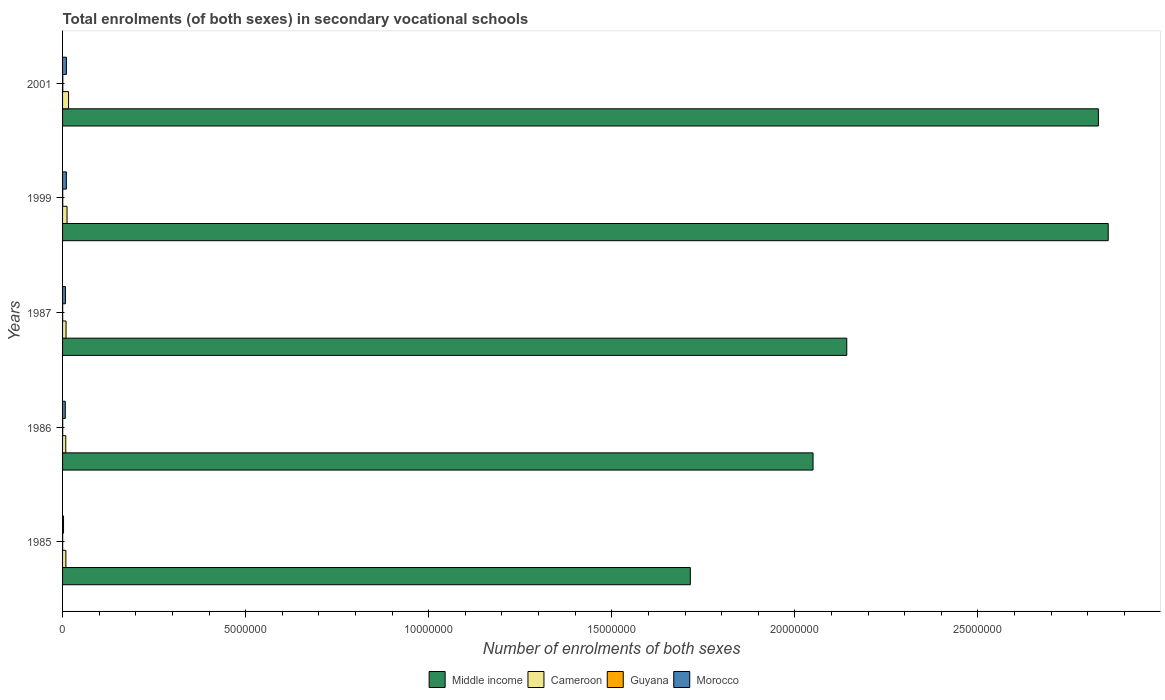How many bars are there on the 1st tick from the top?
Keep it short and to the point. 4. What is the number of enrolments in secondary schools in Cameroon in 1999?
Keep it short and to the point. 1.22e+05. Across all years, what is the maximum number of enrolments in secondary schools in Cameroon?
Your response must be concise. 1.64e+05. Across all years, what is the minimum number of enrolments in secondary schools in Morocco?
Ensure brevity in your answer.  2.65e+04. In which year was the number of enrolments in secondary schools in Guyana minimum?
Provide a succinct answer. 1985. What is the total number of enrolments in secondary schools in Morocco in the graph?
Keep it short and to the point. 3.86e+05. What is the difference between the number of enrolments in secondary schools in Middle income in 1987 and that in 1999?
Provide a succinct answer. -7.14e+06. What is the difference between the number of enrolments in secondary schools in Cameroon in 1985 and the number of enrolments in secondary schools in Middle income in 2001?
Your answer should be compact. -2.82e+07. What is the average number of enrolments in secondary schools in Cameroon per year?
Keep it short and to the point. 1.12e+05. In the year 1999, what is the difference between the number of enrolments in secondary schools in Middle income and number of enrolments in secondary schools in Morocco?
Give a very brief answer. 2.85e+07. In how many years, is the number of enrolments in secondary schools in Morocco greater than 25000000 ?
Your answer should be very brief. 0. What is the ratio of the number of enrolments in secondary schools in Cameroon in 1999 to that in 2001?
Provide a short and direct response. 0.75. What is the difference between the highest and the second highest number of enrolments in secondary schools in Guyana?
Your response must be concise. 1757. What is the difference between the highest and the lowest number of enrolments in secondary schools in Morocco?
Your response must be concise. 7.82e+04. Is it the case that in every year, the sum of the number of enrolments in secondary schools in Cameroon and number of enrolments in secondary schools in Morocco is greater than the sum of number of enrolments in secondary schools in Middle income and number of enrolments in secondary schools in Guyana?
Provide a short and direct response. No. Is it the case that in every year, the sum of the number of enrolments in secondary schools in Cameroon and number of enrolments in secondary schools in Morocco is greater than the number of enrolments in secondary schools in Middle income?
Your answer should be very brief. No. How many bars are there?
Offer a very short reply. 20. Are all the bars in the graph horizontal?
Your response must be concise. Yes. Does the graph contain any zero values?
Offer a terse response. No. Does the graph contain grids?
Ensure brevity in your answer.  No. Where does the legend appear in the graph?
Ensure brevity in your answer.  Bottom center. What is the title of the graph?
Provide a succinct answer. Total enrolments (of both sexes) in secondary vocational schools. Does "High income" appear as one of the legend labels in the graph?
Your answer should be compact. No. What is the label or title of the X-axis?
Make the answer very short. Number of enrolments of both sexes. What is the Number of enrolments of both sexes in Middle income in 1985?
Provide a short and direct response. 1.71e+07. What is the Number of enrolments of both sexes in Cameroon in 1985?
Offer a very short reply. 9.03e+04. What is the Number of enrolments of both sexes in Guyana in 1985?
Provide a short and direct response. 2509. What is the Number of enrolments of both sexes of Morocco in 1985?
Ensure brevity in your answer.  2.65e+04. What is the Number of enrolments of both sexes in Middle income in 1986?
Your answer should be compact. 2.05e+07. What is the Number of enrolments of both sexes in Cameroon in 1986?
Ensure brevity in your answer.  8.73e+04. What is the Number of enrolments of both sexes in Guyana in 1986?
Provide a succinct answer. 3867. What is the Number of enrolments of both sexes in Morocco in 1986?
Make the answer very short. 7.41e+04. What is the Number of enrolments of both sexes in Middle income in 1987?
Your answer should be very brief. 2.14e+07. What is the Number of enrolments of both sexes of Cameroon in 1987?
Your response must be concise. 9.50e+04. What is the Number of enrolments of both sexes in Guyana in 1987?
Offer a very short reply. 2594. What is the Number of enrolments of both sexes in Morocco in 1987?
Offer a terse response. 7.75e+04. What is the Number of enrolments of both sexes in Middle income in 1999?
Keep it short and to the point. 2.86e+07. What is the Number of enrolments of both sexes in Cameroon in 1999?
Your answer should be very brief. 1.22e+05. What is the Number of enrolments of both sexes of Guyana in 1999?
Keep it short and to the point. 4453. What is the Number of enrolments of both sexes of Morocco in 1999?
Offer a very short reply. 1.03e+05. What is the Number of enrolments of both sexes in Middle income in 2001?
Offer a very short reply. 2.83e+07. What is the Number of enrolments of both sexes of Cameroon in 2001?
Your response must be concise. 1.64e+05. What is the Number of enrolments of both sexes of Guyana in 2001?
Offer a terse response. 6210. What is the Number of enrolments of both sexes in Morocco in 2001?
Keep it short and to the point. 1.05e+05. Across all years, what is the maximum Number of enrolments of both sexes of Middle income?
Your answer should be compact. 2.86e+07. Across all years, what is the maximum Number of enrolments of both sexes in Cameroon?
Ensure brevity in your answer.  1.64e+05. Across all years, what is the maximum Number of enrolments of both sexes of Guyana?
Your response must be concise. 6210. Across all years, what is the maximum Number of enrolments of both sexes of Morocco?
Your response must be concise. 1.05e+05. Across all years, what is the minimum Number of enrolments of both sexes in Middle income?
Keep it short and to the point. 1.71e+07. Across all years, what is the minimum Number of enrolments of both sexes in Cameroon?
Offer a terse response. 8.73e+04. Across all years, what is the minimum Number of enrolments of both sexes of Guyana?
Keep it short and to the point. 2509. Across all years, what is the minimum Number of enrolments of both sexes of Morocco?
Your response must be concise. 2.65e+04. What is the total Number of enrolments of both sexes in Middle income in the graph?
Your answer should be very brief. 1.16e+08. What is the total Number of enrolments of both sexes in Cameroon in the graph?
Your answer should be very brief. 5.58e+05. What is the total Number of enrolments of both sexes in Guyana in the graph?
Your response must be concise. 1.96e+04. What is the total Number of enrolments of both sexes in Morocco in the graph?
Your answer should be compact. 3.86e+05. What is the difference between the Number of enrolments of both sexes in Middle income in 1985 and that in 1986?
Your answer should be very brief. -3.35e+06. What is the difference between the Number of enrolments of both sexes of Cameroon in 1985 and that in 1986?
Your answer should be very brief. 3081. What is the difference between the Number of enrolments of both sexes in Guyana in 1985 and that in 1986?
Give a very brief answer. -1358. What is the difference between the Number of enrolments of both sexes of Morocco in 1985 and that in 1986?
Your response must be concise. -4.76e+04. What is the difference between the Number of enrolments of both sexes of Middle income in 1985 and that in 1987?
Provide a short and direct response. -4.27e+06. What is the difference between the Number of enrolments of both sexes in Cameroon in 1985 and that in 1987?
Make the answer very short. -4677. What is the difference between the Number of enrolments of both sexes of Guyana in 1985 and that in 1987?
Offer a terse response. -85. What is the difference between the Number of enrolments of both sexes in Morocco in 1985 and that in 1987?
Keep it short and to the point. -5.10e+04. What is the difference between the Number of enrolments of both sexes of Middle income in 1985 and that in 1999?
Give a very brief answer. -1.14e+07. What is the difference between the Number of enrolments of both sexes in Cameroon in 1985 and that in 1999?
Make the answer very short. -3.18e+04. What is the difference between the Number of enrolments of both sexes of Guyana in 1985 and that in 1999?
Offer a terse response. -1944. What is the difference between the Number of enrolments of both sexes of Morocco in 1985 and that in 1999?
Offer a very short reply. -7.69e+04. What is the difference between the Number of enrolments of both sexes of Middle income in 1985 and that in 2001?
Keep it short and to the point. -1.11e+07. What is the difference between the Number of enrolments of both sexes in Cameroon in 1985 and that in 2001?
Ensure brevity in your answer.  -7.33e+04. What is the difference between the Number of enrolments of both sexes in Guyana in 1985 and that in 2001?
Provide a short and direct response. -3701. What is the difference between the Number of enrolments of both sexes of Morocco in 1985 and that in 2001?
Your answer should be very brief. -7.82e+04. What is the difference between the Number of enrolments of both sexes of Middle income in 1986 and that in 1987?
Offer a terse response. -9.21e+05. What is the difference between the Number of enrolments of both sexes in Cameroon in 1986 and that in 1987?
Your answer should be very brief. -7758. What is the difference between the Number of enrolments of both sexes of Guyana in 1986 and that in 1987?
Provide a succinct answer. 1273. What is the difference between the Number of enrolments of both sexes in Morocco in 1986 and that in 1987?
Give a very brief answer. -3397. What is the difference between the Number of enrolments of both sexes in Middle income in 1986 and that in 1999?
Your answer should be compact. -8.06e+06. What is the difference between the Number of enrolments of both sexes of Cameroon in 1986 and that in 1999?
Keep it short and to the point. -3.49e+04. What is the difference between the Number of enrolments of both sexes of Guyana in 1986 and that in 1999?
Your answer should be very brief. -586. What is the difference between the Number of enrolments of both sexes in Morocco in 1986 and that in 1999?
Give a very brief answer. -2.93e+04. What is the difference between the Number of enrolments of both sexes of Middle income in 1986 and that in 2001?
Offer a terse response. -7.79e+06. What is the difference between the Number of enrolments of both sexes in Cameroon in 1986 and that in 2001?
Offer a terse response. -7.64e+04. What is the difference between the Number of enrolments of both sexes of Guyana in 1986 and that in 2001?
Make the answer very short. -2343. What is the difference between the Number of enrolments of both sexes of Morocco in 1986 and that in 2001?
Provide a succinct answer. -3.06e+04. What is the difference between the Number of enrolments of both sexes of Middle income in 1987 and that in 1999?
Give a very brief answer. -7.14e+06. What is the difference between the Number of enrolments of both sexes of Cameroon in 1987 and that in 1999?
Provide a succinct answer. -2.71e+04. What is the difference between the Number of enrolments of both sexes of Guyana in 1987 and that in 1999?
Offer a very short reply. -1859. What is the difference between the Number of enrolments of both sexes of Morocco in 1987 and that in 1999?
Provide a short and direct response. -2.59e+04. What is the difference between the Number of enrolments of both sexes in Middle income in 1987 and that in 2001?
Your response must be concise. -6.87e+06. What is the difference between the Number of enrolments of both sexes in Cameroon in 1987 and that in 2001?
Give a very brief answer. -6.86e+04. What is the difference between the Number of enrolments of both sexes in Guyana in 1987 and that in 2001?
Provide a short and direct response. -3616. What is the difference between the Number of enrolments of both sexes in Morocco in 1987 and that in 2001?
Your answer should be compact. -2.72e+04. What is the difference between the Number of enrolments of both sexes of Middle income in 1999 and that in 2001?
Offer a terse response. 2.69e+05. What is the difference between the Number of enrolments of both sexes in Cameroon in 1999 and that in 2001?
Offer a terse response. -4.15e+04. What is the difference between the Number of enrolments of both sexes in Guyana in 1999 and that in 2001?
Give a very brief answer. -1757. What is the difference between the Number of enrolments of both sexes of Morocco in 1999 and that in 2001?
Ensure brevity in your answer.  -1297. What is the difference between the Number of enrolments of both sexes of Middle income in 1985 and the Number of enrolments of both sexes of Cameroon in 1986?
Give a very brief answer. 1.71e+07. What is the difference between the Number of enrolments of both sexes of Middle income in 1985 and the Number of enrolments of both sexes of Guyana in 1986?
Ensure brevity in your answer.  1.71e+07. What is the difference between the Number of enrolments of both sexes of Middle income in 1985 and the Number of enrolments of both sexes of Morocco in 1986?
Make the answer very short. 1.71e+07. What is the difference between the Number of enrolments of both sexes in Cameroon in 1985 and the Number of enrolments of both sexes in Guyana in 1986?
Keep it short and to the point. 8.65e+04. What is the difference between the Number of enrolments of both sexes in Cameroon in 1985 and the Number of enrolments of both sexes in Morocco in 1986?
Give a very brief answer. 1.62e+04. What is the difference between the Number of enrolments of both sexes of Guyana in 1985 and the Number of enrolments of both sexes of Morocco in 1986?
Offer a very short reply. -7.16e+04. What is the difference between the Number of enrolments of both sexes of Middle income in 1985 and the Number of enrolments of both sexes of Cameroon in 1987?
Offer a terse response. 1.70e+07. What is the difference between the Number of enrolments of both sexes of Middle income in 1985 and the Number of enrolments of both sexes of Guyana in 1987?
Make the answer very short. 1.71e+07. What is the difference between the Number of enrolments of both sexes in Middle income in 1985 and the Number of enrolments of both sexes in Morocco in 1987?
Give a very brief answer. 1.71e+07. What is the difference between the Number of enrolments of both sexes in Cameroon in 1985 and the Number of enrolments of both sexes in Guyana in 1987?
Keep it short and to the point. 8.78e+04. What is the difference between the Number of enrolments of both sexes in Cameroon in 1985 and the Number of enrolments of both sexes in Morocco in 1987?
Provide a succinct answer. 1.28e+04. What is the difference between the Number of enrolments of both sexes of Guyana in 1985 and the Number of enrolments of both sexes of Morocco in 1987?
Make the answer very short. -7.50e+04. What is the difference between the Number of enrolments of both sexes in Middle income in 1985 and the Number of enrolments of both sexes in Cameroon in 1999?
Provide a short and direct response. 1.70e+07. What is the difference between the Number of enrolments of both sexes of Middle income in 1985 and the Number of enrolments of both sexes of Guyana in 1999?
Make the answer very short. 1.71e+07. What is the difference between the Number of enrolments of both sexes in Middle income in 1985 and the Number of enrolments of both sexes in Morocco in 1999?
Give a very brief answer. 1.70e+07. What is the difference between the Number of enrolments of both sexes of Cameroon in 1985 and the Number of enrolments of both sexes of Guyana in 1999?
Your answer should be compact. 8.59e+04. What is the difference between the Number of enrolments of both sexes of Cameroon in 1985 and the Number of enrolments of both sexes of Morocco in 1999?
Your answer should be very brief. -1.31e+04. What is the difference between the Number of enrolments of both sexes of Guyana in 1985 and the Number of enrolments of both sexes of Morocco in 1999?
Keep it short and to the point. -1.01e+05. What is the difference between the Number of enrolments of both sexes in Middle income in 1985 and the Number of enrolments of both sexes in Cameroon in 2001?
Your answer should be very brief. 1.70e+07. What is the difference between the Number of enrolments of both sexes of Middle income in 1985 and the Number of enrolments of both sexes of Guyana in 2001?
Keep it short and to the point. 1.71e+07. What is the difference between the Number of enrolments of both sexes of Middle income in 1985 and the Number of enrolments of both sexes of Morocco in 2001?
Give a very brief answer. 1.70e+07. What is the difference between the Number of enrolments of both sexes in Cameroon in 1985 and the Number of enrolments of both sexes in Guyana in 2001?
Provide a succinct answer. 8.41e+04. What is the difference between the Number of enrolments of both sexes of Cameroon in 1985 and the Number of enrolments of both sexes of Morocco in 2001?
Your answer should be compact. -1.44e+04. What is the difference between the Number of enrolments of both sexes of Guyana in 1985 and the Number of enrolments of both sexes of Morocco in 2001?
Make the answer very short. -1.02e+05. What is the difference between the Number of enrolments of both sexes in Middle income in 1986 and the Number of enrolments of both sexes in Cameroon in 1987?
Provide a short and direct response. 2.04e+07. What is the difference between the Number of enrolments of both sexes of Middle income in 1986 and the Number of enrolments of both sexes of Guyana in 1987?
Provide a succinct answer. 2.05e+07. What is the difference between the Number of enrolments of both sexes of Middle income in 1986 and the Number of enrolments of both sexes of Morocco in 1987?
Your answer should be compact. 2.04e+07. What is the difference between the Number of enrolments of both sexes of Cameroon in 1986 and the Number of enrolments of both sexes of Guyana in 1987?
Your answer should be compact. 8.47e+04. What is the difference between the Number of enrolments of both sexes in Cameroon in 1986 and the Number of enrolments of both sexes in Morocco in 1987?
Keep it short and to the point. 9767. What is the difference between the Number of enrolments of both sexes in Guyana in 1986 and the Number of enrolments of both sexes in Morocco in 1987?
Your answer should be compact. -7.36e+04. What is the difference between the Number of enrolments of both sexes of Middle income in 1986 and the Number of enrolments of both sexes of Cameroon in 1999?
Your answer should be compact. 2.04e+07. What is the difference between the Number of enrolments of both sexes of Middle income in 1986 and the Number of enrolments of both sexes of Guyana in 1999?
Provide a short and direct response. 2.05e+07. What is the difference between the Number of enrolments of both sexes in Middle income in 1986 and the Number of enrolments of both sexes in Morocco in 1999?
Your answer should be very brief. 2.04e+07. What is the difference between the Number of enrolments of both sexes of Cameroon in 1986 and the Number of enrolments of both sexes of Guyana in 1999?
Provide a succinct answer. 8.28e+04. What is the difference between the Number of enrolments of both sexes in Cameroon in 1986 and the Number of enrolments of both sexes in Morocco in 1999?
Give a very brief answer. -1.62e+04. What is the difference between the Number of enrolments of both sexes in Guyana in 1986 and the Number of enrolments of both sexes in Morocco in 1999?
Your response must be concise. -9.96e+04. What is the difference between the Number of enrolments of both sexes of Middle income in 1986 and the Number of enrolments of both sexes of Cameroon in 2001?
Keep it short and to the point. 2.03e+07. What is the difference between the Number of enrolments of both sexes in Middle income in 1986 and the Number of enrolments of both sexes in Guyana in 2001?
Provide a succinct answer. 2.05e+07. What is the difference between the Number of enrolments of both sexes in Middle income in 1986 and the Number of enrolments of both sexes in Morocco in 2001?
Make the answer very short. 2.04e+07. What is the difference between the Number of enrolments of both sexes in Cameroon in 1986 and the Number of enrolments of both sexes in Guyana in 2001?
Provide a succinct answer. 8.11e+04. What is the difference between the Number of enrolments of both sexes of Cameroon in 1986 and the Number of enrolments of both sexes of Morocco in 2001?
Your answer should be very brief. -1.75e+04. What is the difference between the Number of enrolments of both sexes in Guyana in 1986 and the Number of enrolments of both sexes in Morocco in 2001?
Make the answer very short. -1.01e+05. What is the difference between the Number of enrolments of both sexes in Middle income in 1987 and the Number of enrolments of both sexes in Cameroon in 1999?
Keep it short and to the point. 2.13e+07. What is the difference between the Number of enrolments of both sexes of Middle income in 1987 and the Number of enrolments of both sexes of Guyana in 1999?
Make the answer very short. 2.14e+07. What is the difference between the Number of enrolments of both sexes of Middle income in 1987 and the Number of enrolments of both sexes of Morocco in 1999?
Give a very brief answer. 2.13e+07. What is the difference between the Number of enrolments of both sexes in Cameroon in 1987 and the Number of enrolments of both sexes in Guyana in 1999?
Offer a very short reply. 9.06e+04. What is the difference between the Number of enrolments of both sexes of Cameroon in 1987 and the Number of enrolments of both sexes of Morocco in 1999?
Give a very brief answer. -8423. What is the difference between the Number of enrolments of both sexes in Guyana in 1987 and the Number of enrolments of both sexes in Morocco in 1999?
Offer a terse response. -1.01e+05. What is the difference between the Number of enrolments of both sexes of Middle income in 1987 and the Number of enrolments of both sexes of Cameroon in 2001?
Offer a very short reply. 2.13e+07. What is the difference between the Number of enrolments of both sexes of Middle income in 1987 and the Number of enrolments of both sexes of Guyana in 2001?
Your answer should be compact. 2.14e+07. What is the difference between the Number of enrolments of both sexes of Middle income in 1987 and the Number of enrolments of both sexes of Morocco in 2001?
Your response must be concise. 2.13e+07. What is the difference between the Number of enrolments of both sexes in Cameroon in 1987 and the Number of enrolments of both sexes in Guyana in 2001?
Make the answer very short. 8.88e+04. What is the difference between the Number of enrolments of both sexes of Cameroon in 1987 and the Number of enrolments of both sexes of Morocco in 2001?
Your response must be concise. -9720. What is the difference between the Number of enrolments of both sexes in Guyana in 1987 and the Number of enrolments of both sexes in Morocco in 2001?
Offer a terse response. -1.02e+05. What is the difference between the Number of enrolments of both sexes of Middle income in 1999 and the Number of enrolments of both sexes of Cameroon in 2001?
Keep it short and to the point. 2.84e+07. What is the difference between the Number of enrolments of both sexes in Middle income in 1999 and the Number of enrolments of both sexes in Guyana in 2001?
Make the answer very short. 2.86e+07. What is the difference between the Number of enrolments of both sexes in Middle income in 1999 and the Number of enrolments of both sexes in Morocco in 2001?
Give a very brief answer. 2.85e+07. What is the difference between the Number of enrolments of both sexes of Cameroon in 1999 and the Number of enrolments of both sexes of Guyana in 2001?
Offer a terse response. 1.16e+05. What is the difference between the Number of enrolments of both sexes in Cameroon in 1999 and the Number of enrolments of both sexes in Morocco in 2001?
Your answer should be compact. 1.74e+04. What is the difference between the Number of enrolments of both sexes of Guyana in 1999 and the Number of enrolments of both sexes of Morocco in 2001?
Your answer should be compact. -1.00e+05. What is the average Number of enrolments of both sexes in Middle income per year?
Give a very brief answer. 2.32e+07. What is the average Number of enrolments of both sexes of Cameroon per year?
Provide a short and direct response. 1.12e+05. What is the average Number of enrolments of both sexes of Guyana per year?
Your response must be concise. 3926.6. What is the average Number of enrolments of both sexes of Morocco per year?
Your answer should be very brief. 7.73e+04. In the year 1985, what is the difference between the Number of enrolments of both sexes of Middle income and Number of enrolments of both sexes of Cameroon?
Give a very brief answer. 1.71e+07. In the year 1985, what is the difference between the Number of enrolments of both sexes of Middle income and Number of enrolments of both sexes of Guyana?
Provide a succinct answer. 1.71e+07. In the year 1985, what is the difference between the Number of enrolments of both sexes of Middle income and Number of enrolments of both sexes of Morocco?
Offer a terse response. 1.71e+07. In the year 1985, what is the difference between the Number of enrolments of both sexes of Cameroon and Number of enrolments of both sexes of Guyana?
Ensure brevity in your answer.  8.78e+04. In the year 1985, what is the difference between the Number of enrolments of both sexes of Cameroon and Number of enrolments of both sexes of Morocco?
Offer a very short reply. 6.38e+04. In the year 1985, what is the difference between the Number of enrolments of both sexes of Guyana and Number of enrolments of both sexes of Morocco?
Your answer should be compact. -2.40e+04. In the year 1986, what is the difference between the Number of enrolments of both sexes in Middle income and Number of enrolments of both sexes in Cameroon?
Make the answer very short. 2.04e+07. In the year 1986, what is the difference between the Number of enrolments of both sexes of Middle income and Number of enrolments of both sexes of Guyana?
Give a very brief answer. 2.05e+07. In the year 1986, what is the difference between the Number of enrolments of both sexes in Middle income and Number of enrolments of both sexes in Morocco?
Provide a short and direct response. 2.04e+07. In the year 1986, what is the difference between the Number of enrolments of both sexes of Cameroon and Number of enrolments of both sexes of Guyana?
Make the answer very short. 8.34e+04. In the year 1986, what is the difference between the Number of enrolments of both sexes of Cameroon and Number of enrolments of both sexes of Morocco?
Your response must be concise. 1.32e+04. In the year 1986, what is the difference between the Number of enrolments of both sexes of Guyana and Number of enrolments of both sexes of Morocco?
Provide a short and direct response. -7.02e+04. In the year 1987, what is the difference between the Number of enrolments of both sexes in Middle income and Number of enrolments of both sexes in Cameroon?
Your answer should be very brief. 2.13e+07. In the year 1987, what is the difference between the Number of enrolments of both sexes in Middle income and Number of enrolments of both sexes in Guyana?
Ensure brevity in your answer.  2.14e+07. In the year 1987, what is the difference between the Number of enrolments of both sexes of Middle income and Number of enrolments of both sexes of Morocco?
Make the answer very short. 2.13e+07. In the year 1987, what is the difference between the Number of enrolments of both sexes in Cameroon and Number of enrolments of both sexes in Guyana?
Give a very brief answer. 9.24e+04. In the year 1987, what is the difference between the Number of enrolments of both sexes of Cameroon and Number of enrolments of both sexes of Morocco?
Provide a short and direct response. 1.75e+04. In the year 1987, what is the difference between the Number of enrolments of both sexes of Guyana and Number of enrolments of both sexes of Morocco?
Your answer should be very brief. -7.49e+04. In the year 1999, what is the difference between the Number of enrolments of both sexes in Middle income and Number of enrolments of both sexes in Cameroon?
Your answer should be very brief. 2.84e+07. In the year 1999, what is the difference between the Number of enrolments of both sexes of Middle income and Number of enrolments of both sexes of Guyana?
Your answer should be compact. 2.86e+07. In the year 1999, what is the difference between the Number of enrolments of both sexes in Middle income and Number of enrolments of both sexes in Morocco?
Offer a very short reply. 2.85e+07. In the year 1999, what is the difference between the Number of enrolments of both sexes of Cameroon and Number of enrolments of both sexes of Guyana?
Keep it short and to the point. 1.18e+05. In the year 1999, what is the difference between the Number of enrolments of both sexes of Cameroon and Number of enrolments of both sexes of Morocco?
Offer a terse response. 1.87e+04. In the year 1999, what is the difference between the Number of enrolments of both sexes of Guyana and Number of enrolments of both sexes of Morocco?
Your response must be concise. -9.90e+04. In the year 2001, what is the difference between the Number of enrolments of both sexes of Middle income and Number of enrolments of both sexes of Cameroon?
Make the answer very short. 2.81e+07. In the year 2001, what is the difference between the Number of enrolments of both sexes in Middle income and Number of enrolments of both sexes in Guyana?
Your answer should be compact. 2.83e+07. In the year 2001, what is the difference between the Number of enrolments of both sexes in Middle income and Number of enrolments of both sexes in Morocco?
Offer a very short reply. 2.82e+07. In the year 2001, what is the difference between the Number of enrolments of both sexes in Cameroon and Number of enrolments of both sexes in Guyana?
Ensure brevity in your answer.  1.57e+05. In the year 2001, what is the difference between the Number of enrolments of both sexes of Cameroon and Number of enrolments of both sexes of Morocco?
Your answer should be very brief. 5.89e+04. In the year 2001, what is the difference between the Number of enrolments of both sexes of Guyana and Number of enrolments of both sexes of Morocco?
Keep it short and to the point. -9.85e+04. What is the ratio of the Number of enrolments of both sexes in Middle income in 1985 to that in 1986?
Provide a short and direct response. 0.84. What is the ratio of the Number of enrolments of both sexes in Cameroon in 1985 to that in 1986?
Provide a short and direct response. 1.04. What is the ratio of the Number of enrolments of both sexes in Guyana in 1985 to that in 1986?
Ensure brevity in your answer.  0.65. What is the ratio of the Number of enrolments of both sexes in Morocco in 1985 to that in 1986?
Keep it short and to the point. 0.36. What is the ratio of the Number of enrolments of both sexes in Middle income in 1985 to that in 1987?
Give a very brief answer. 0.8. What is the ratio of the Number of enrolments of both sexes of Cameroon in 1985 to that in 1987?
Ensure brevity in your answer.  0.95. What is the ratio of the Number of enrolments of both sexes in Guyana in 1985 to that in 1987?
Your answer should be compact. 0.97. What is the ratio of the Number of enrolments of both sexes of Morocco in 1985 to that in 1987?
Provide a short and direct response. 0.34. What is the ratio of the Number of enrolments of both sexes of Middle income in 1985 to that in 1999?
Offer a very short reply. 0.6. What is the ratio of the Number of enrolments of both sexes of Cameroon in 1985 to that in 1999?
Keep it short and to the point. 0.74. What is the ratio of the Number of enrolments of both sexes of Guyana in 1985 to that in 1999?
Make the answer very short. 0.56. What is the ratio of the Number of enrolments of both sexes in Morocco in 1985 to that in 1999?
Your answer should be very brief. 0.26. What is the ratio of the Number of enrolments of both sexes of Middle income in 1985 to that in 2001?
Keep it short and to the point. 0.61. What is the ratio of the Number of enrolments of both sexes of Cameroon in 1985 to that in 2001?
Offer a very short reply. 0.55. What is the ratio of the Number of enrolments of both sexes in Guyana in 1985 to that in 2001?
Offer a terse response. 0.4. What is the ratio of the Number of enrolments of both sexes of Morocco in 1985 to that in 2001?
Your answer should be very brief. 0.25. What is the ratio of the Number of enrolments of both sexes of Cameroon in 1986 to that in 1987?
Keep it short and to the point. 0.92. What is the ratio of the Number of enrolments of both sexes in Guyana in 1986 to that in 1987?
Make the answer very short. 1.49. What is the ratio of the Number of enrolments of both sexes of Morocco in 1986 to that in 1987?
Offer a very short reply. 0.96. What is the ratio of the Number of enrolments of both sexes in Middle income in 1986 to that in 1999?
Keep it short and to the point. 0.72. What is the ratio of the Number of enrolments of both sexes of Cameroon in 1986 to that in 1999?
Offer a very short reply. 0.71. What is the ratio of the Number of enrolments of both sexes in Guyana in 1986 to that in 1999?
Ensure brevity in your answer.  0.87. What is the ratio of the Number of enrolments of both sexes of Morocco in 1986 to that in 1999?
Provide a short and direct response. 0.72. What is the ratio of the Number of enrolments of both sexes of Middle income in 1986 to that in 2001?
Your answer should be very brief. 0.72. What is the ratio of the Number of enrolments of both sexes of Cameroon in 1986 to that in 2001?
Your answer should be very brief. 0.53. What is the ratio of the Number of enrolments of both sexes in Guyana in 1986 to that in 2001?
Give a very brief answer. 0.62. What is the ratio of the Number of enrolments of both sexes of Morocco in 1986 to that in 2001?
Offer a terse response. 0.71. What is the ratio of the Number of enrolments of both sexes in Middle income in 1987 to that in 1999?
Your response must be concise. 0.75. What is the ratio of the Number of enrolments of both sexes in Cameroon in 1987 to that in 1999?
Offer a very short reply. 0.78. What is the ratio of the Number of enrolments of both sexes in Guyana in 1987 to that in 1999?
Provide a short and direct response. 0.58. What is the ratio of the Number of enrolments of both sexes in Morocco in 1987 to that in 1999?
Your answer should be very brief. 0.75. What is the ratio of the Number of enrolments of both sexes of Middle income in 1987 to that in 2001?
Your answer should be compact. 0.76. What is the ratio of the Number of enrolments of both sexes in Cameroon in 1987 to that in 2001?
Offer a terse response. 0.58. What is the ratio of the Number of enrolments of both sexes of Guyana in 1987 to that in 2001?
Your answer should be very brief. 0.42. What is the ratio of the Number of enrolments of both sexes of Morocco in 1987 to that in 2001?
Your response must be concise. 0.74. What is the ratio of the Number of enrolments of both sexes of Middle income in 1999 to that in 2001?
Offer a very short reply. 1.01. What is the ratio of the Number of enrolments of both sexes in Cameroon in 1999 to that in 2001?
Give a very brief answer. 0.75. What is the ratio of the Number of enrolments of both sexes in Guyana in 1999 to that in 2001?
Keep it short and to the point. 0.72. What is the ratio of the Number of enrolments of both sexes of Morocco in 1999 to that in 2001?
Ensure brevity in your answer.  0.99. What is the difference between the highest and the second highest Number of enrolments of both sexes in Middle income?
Give a very brief answer. 2.69e+05. What is the difference between the highest and the second highest Number of enrolments of both sexes of Cameroon?
Your answer should be very brief. 4.15e+04. What is the difference between the highest and the second highest Number of enrolments of both sexes in Guyana?
Your answer should be very brief. 1757. What is the difference between the highest and the second highest Number of enrolments of both sexes in Morocco?
Provide a short and direct response. 1297. What is the difference between the highest and the lowest Number of enrolments of both sexes in Middle income?
Your answer should be very brief. 1.14e+07. What is the difference between the highest and the lowest Number of enrolments of both sexes of Cameroon?
Offer a very short reply. 7.64e+04. What is the difference between the highest and the lowest Number of enrolments of both sexes in Guyana?
Keep it short and to the point. 3701. What is the difference between the highest and the lowest Number of enrolments of both sexes of Morocco?
Keep it short and to the point. 7.82e+04. 